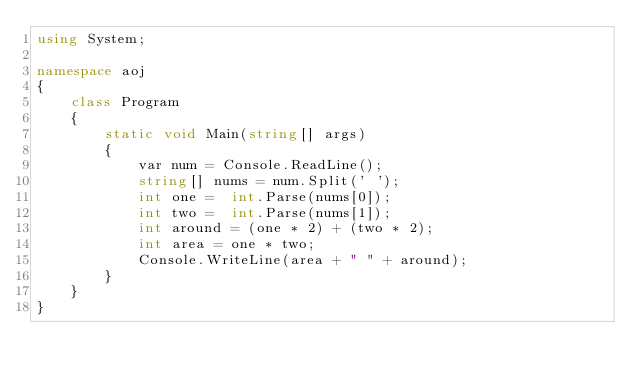<code> <loc_0><loc_0><loc_500><loc_500><_C#_>using System;

namespace aoj
{
    class Program
    {
        static void Main(string[] args)
        {
            var num = Console.ReadLine();
            string[] nums = num.Split(' ');   
            int one =  int.Parse(nums[0]);
            int two =  int.Parse(nums[1]);
            int around = (one * 2) + (two * 2);     
            int area = one * two;     
            Console.WriteLine(area + " " + around);
        }
    }
}

</code> 